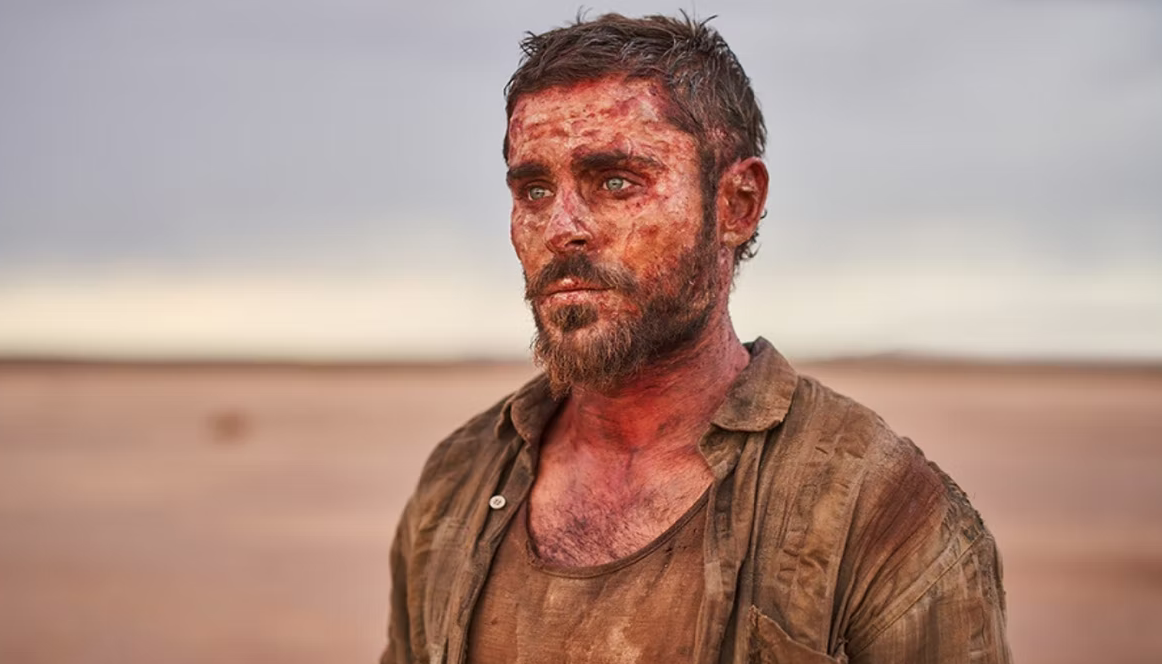Imagine a conversation this character might have with someone if they finally find help. As he meets a helpful stranger, he might say, 'You wouldn’t believe what I've been through. Days without food or water, fighting off wild animals, and braving the scorching heat. Every step felt like a battle, but I couldn't afford to stop. I don't know how I made it this far, but here I am. All I dream of now is a bit of rest and some hope for the future.' What could be the possible reason he ended up in this harsh condition? There could be numerous reasons for his condition. Perhaps he was part of an expedition that went wrong, losing his way and getting separated from his group. He might be a lone wanderer searching for something or someone, driven by a personal mission or quest. Alternatively, he could have survived a plane crash or vehicle breakdown in the desert, leaving him stranded and forced to navigate back to civilization on foot. His appearance suggests a combination of bad luck and immense determination. 